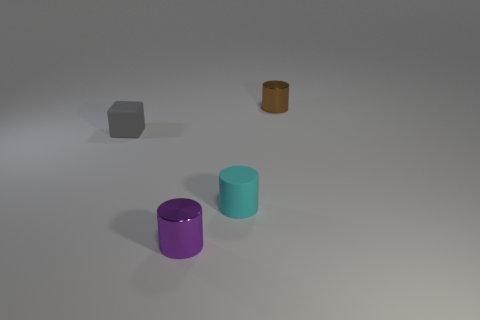Is the material of the cyan object the same as the object that is to the left of the tiny purple cylinder? yes 